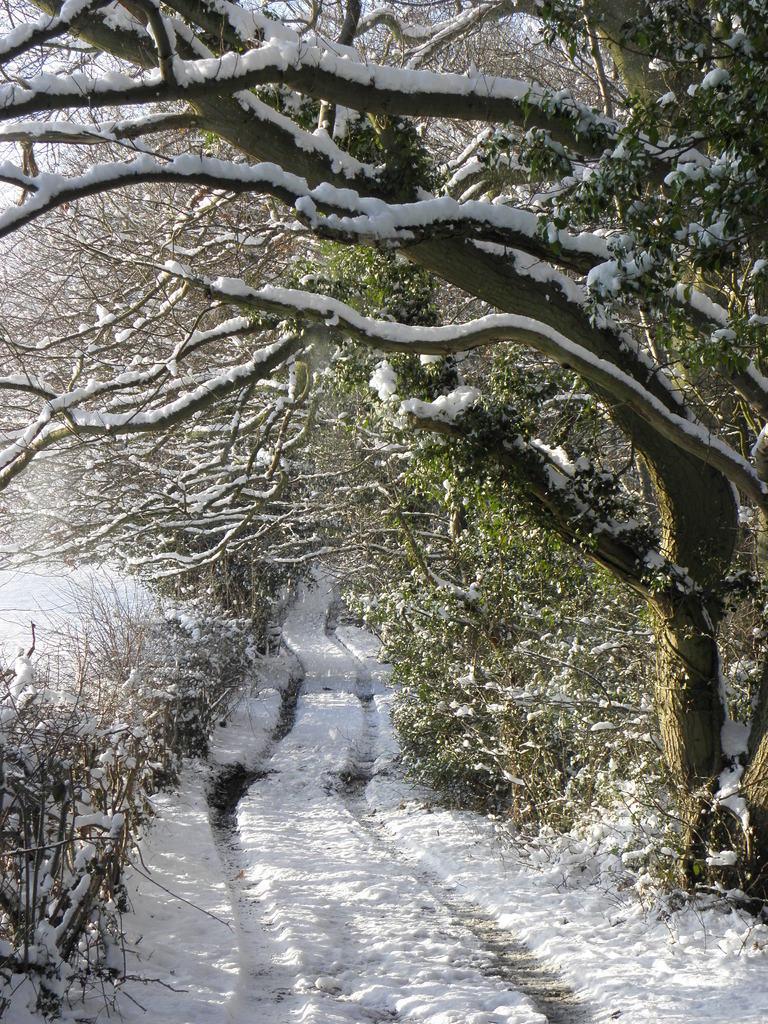In one or two sentences, can you explain what this image depicts? In this picture, there are trees covered with the snow. In the center, there is a land covered with the snow. 